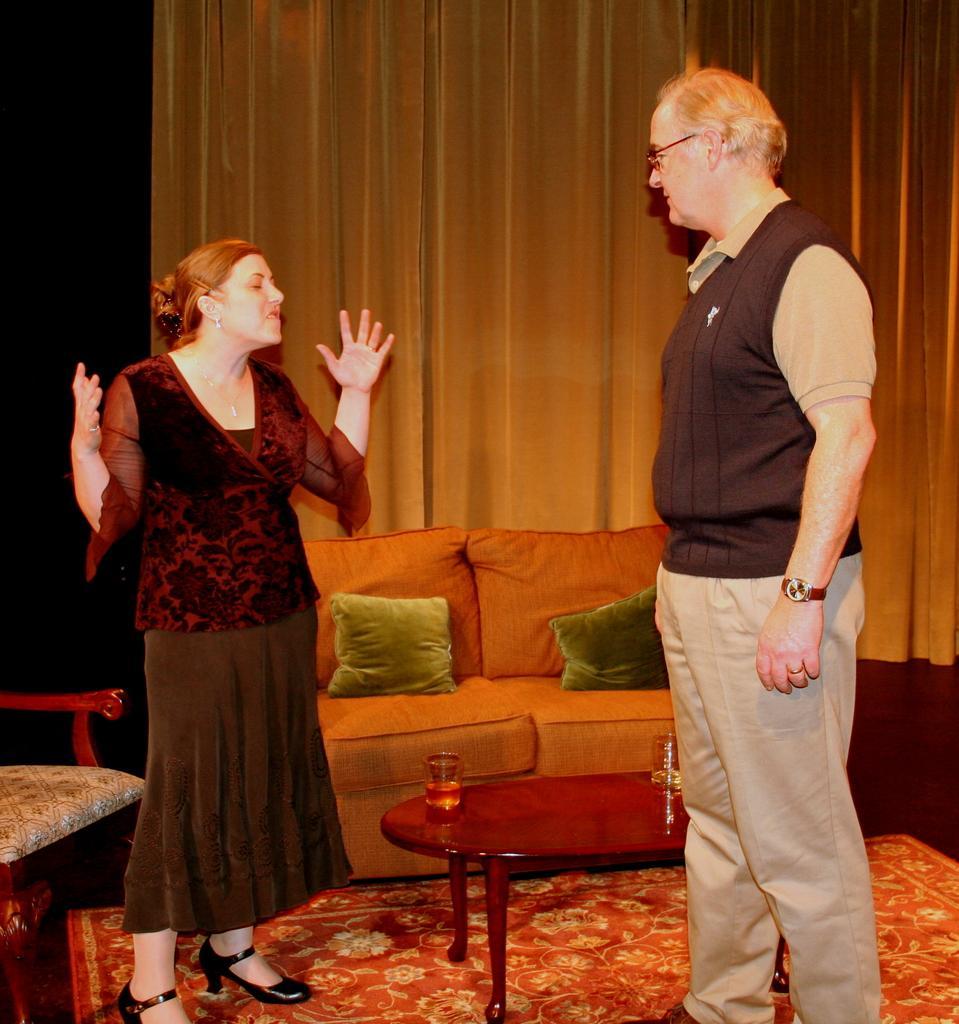Describe this image in one or two sentences. In this image in the front there are persons standing. In the center there is a table and on the table there are glasses. In the background there is a sofa and on the sofa there are cushions. On the left side there is an empty chair and in the background there is a curtain which is behind the sofa. On the floor there is mat. 